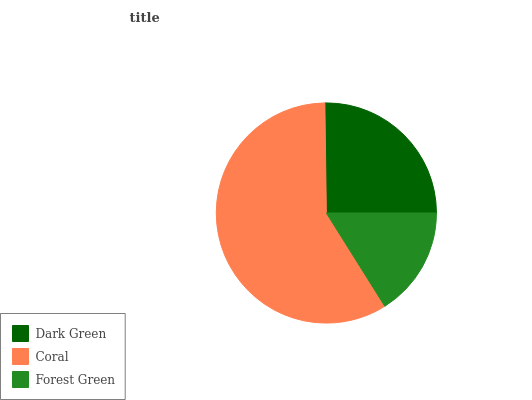Is Forest Green the minimum?
Answer yes or no. Yes. Is Coral the maximum?
Answer yes or no. Yes. Is Coral the minimum?
Answer yes or no. No. Is Forest Green the maximum?
Answer yes or no. No. Is Coral greater than Forest Green?
Answer yes or no. Yes. Is Forest Green less than Coral?
Answer yes or no. Yes. Is Forest Green greater than Coral?
Answer yes or no. No. Is Coral less than Forest Green?
Answer yes or no. No. Is Dark Green the high median?
Answer yes or no. Yes. Is Dark Green the low median?
Answer yes or no. Yes. Is Coral the high median?
Answer yes or no. No. Is Forest Green the low median?
Answer yes or no. No. 